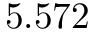Convert formula to latex. <formula><loc_0><loc_0><loc_500><loc_500>5 . 5 7 2</formula> 